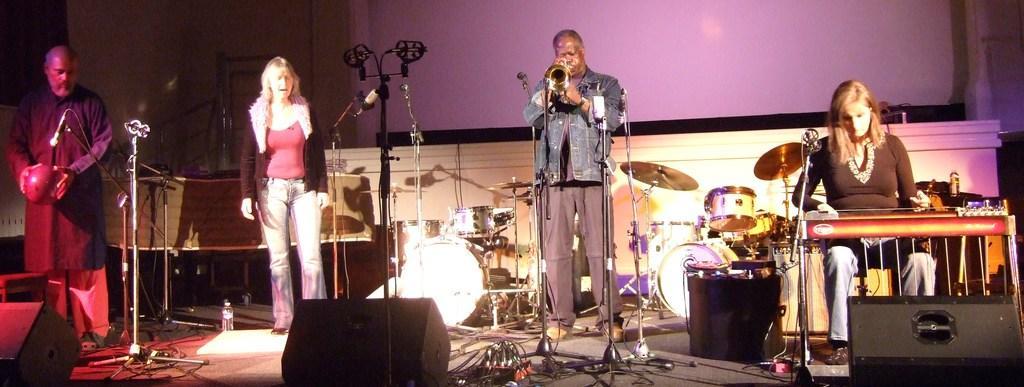How would you summarize this image in a sentence or two? In this image we can see persons standing and performing on the floor. On the right side of the image we can see woman sitting at the musical instrument. In the background we can see mice and musical instruments. In the background we can see speakers, wires and water bottle. 